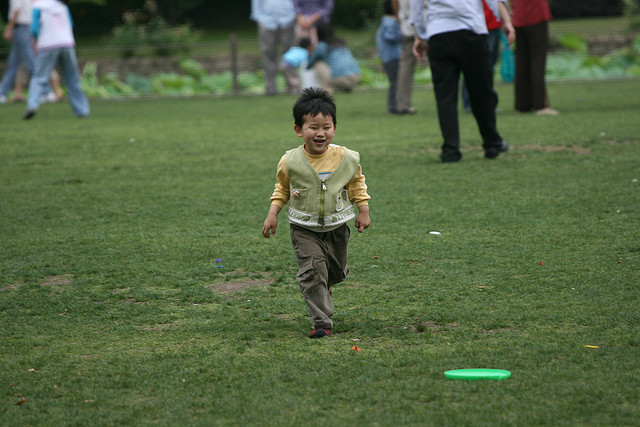What's the weather like in the image? The weather appears to be mild and overcast, as there are no harsh shadows on the ground, and the child is wearing a long-sleeved top, indicating it is not too hot. 